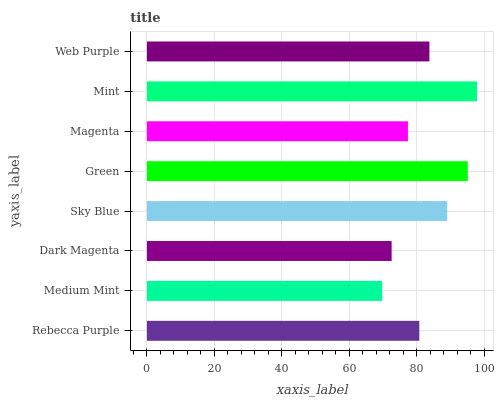Is Medium Mint the minimum?
Answer yes or no. Yes. Is Mint the maximum?
Answer yes or no. Yes. Is Dark Magenta the minimum?
Answer yes or no. No. Is Dark Magenta the maximum?
Answer yes or no. No. Is Dark Magenta greater than Medium Mint?
Answer yes or no. Yes. Is Medium Mint less than Dark Magenta?
Answer yes or no. Yes. Is Medium Mint greater than Dark Magenta?
Answer yes or no. No. Is Dark Magenta less than Medium Mint?
Answer yes or no. No. Is Web Purple the high median?
Answer yes or no. Yes. Is Rebecca Purple the low median?
Answer yes or no. Yes. Is Mint the high median?
Answer yes or no. No. Is Green the low median?
Answer yes or no. No. 